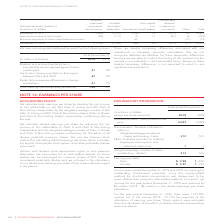According to Rogers Communications's financial document, Which accounting for outstanding share-based payments method was determined to be dilutive? accounting for outstanding share-based payments using the equity-settled method for stock-based compensation was determined to be more dilutive than using the cash-settled method.. The document states: "For the years ended December 31, 2019 and 2018, accounting for outstanding share-based payments using the equity-settled method for stock-based compen..." Also, How much did the net income reduced for the year ended December 31, 2019? net income for the year ended December 31, 2019 was reduced by $6 million (2018 – $2 million) in the diluted earnings per share calculation.. The document states: "e than using the cash-settled method. As a result, net income for the year ended December 31, 2019 was reduced by $6 million (2018 – $2 million) in th..." Also, For the year ended December 31, 2019, how much was the options out of the money for purposes of the calculation of earnings per share? For the year ended December 31, 2019, there were 1,077,875 options out of the money (2018 – 37,715) for purposes of the calculation of earnings per share.. The document states: "For the year ended December 31, 2019, there were 1,077,875 options out of the money (2018 – 37,715) for purposes of the calculation of earnings per sh..." Also, can you calculate: What is the increase/ (decrease) in Numerator (basic) – Net income from 2018 to 2019? Based on the calculation: 2,043-2,059 , the result is -16 (in millions). This is based on the information: "Numerator (basic) – Net income for the year 2,043 2,059 Numerator (basic) – Net income for the year 2,043 2,059..." The key data points involved are: 2,043, 2,059. Also, can you calculate: What is the increase/ (decrease) in Basic Earnings per share from 2018 to 2019? Based on the calculation: 3.99-4.00, the result is -0.01. This is based on the information: "Earnings per share: Basic $ 3.99 $ 4.00 Diluted $ 3.97 $ 3.99 Earnings per share: Basic $ 3.99 $ 4.00 Diluted $ 3.97 $ 3.99..." The key data points involved are: 3.99, 4.00. Also, can you calculate: What is the increase/ (decrease) in Diluted Earnings per share from 2018 to 2019? Based on the calculation: 3.97-3.99, the result is -0.02. This is based on the information: "Earnings per share: Basic $ 3.99 $ 4.00 Diluted $ 3.97 $ 3.99 Earnings per share: Basic $ 3.99 $ 4.00 Diluted $ 3.97 $ 3.99..." The key data points involved are: 3.97, 3.99. 